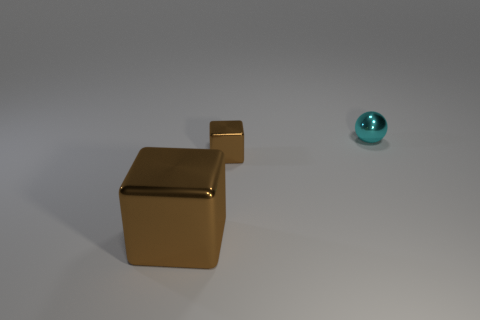Add 3 small shiny objects. How many objects exist? 6 Subtract all gray metal cubes. Subtract all big metallic blocks. How many objects are left? 2 Add 3 small blocks. How many small blocks are left? 4 Add 1 small cyan metallic objects. How many small cyan metallic objects exist? 2 Subtract 0 red balls. How many objects are left? 3 Subtract all blocks. How many objects are left? 1 Subtract all purple cubes. Subtract all green spheres. How many cubes are left? 2 Subtract all red spheres. How many green cubes are left? 0 